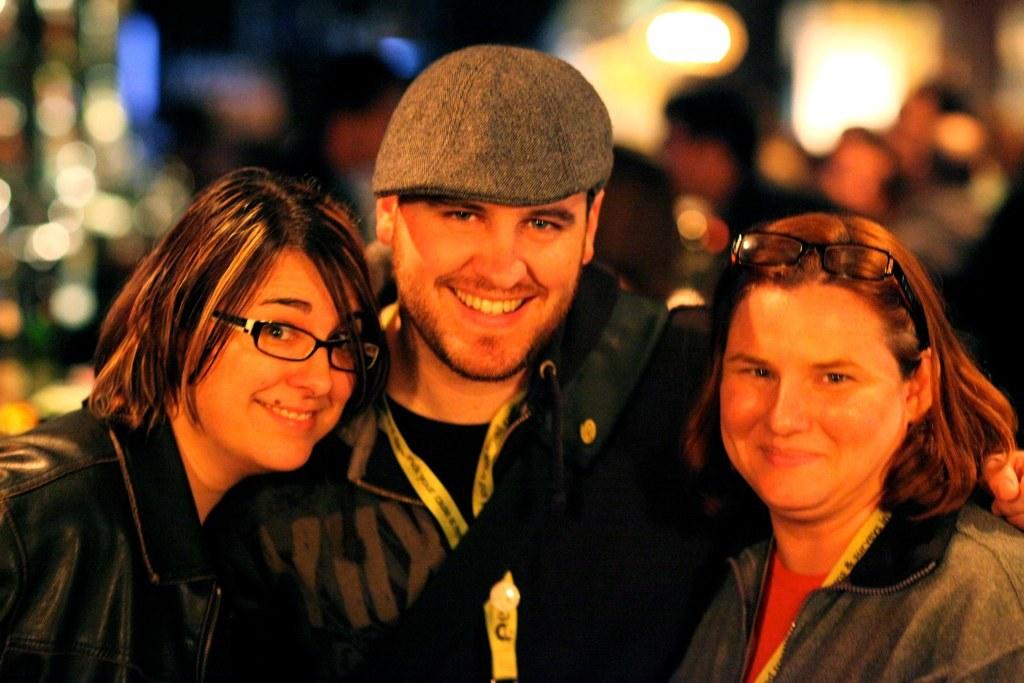How many people are in the foreground of the image? There are three persons in the foreground of the image. What can be seen in the background of the image? There is a crowd in the background of the image. What is illuminating the scene in the image? There are lights visible in the image. What type of location might the image have been taken in? The image may have been taken in a hall. What type of fan is visible in the image? There is no fan present in the image. How does the paste help the people in the image? There is no paste mentioned or visible in the image. 